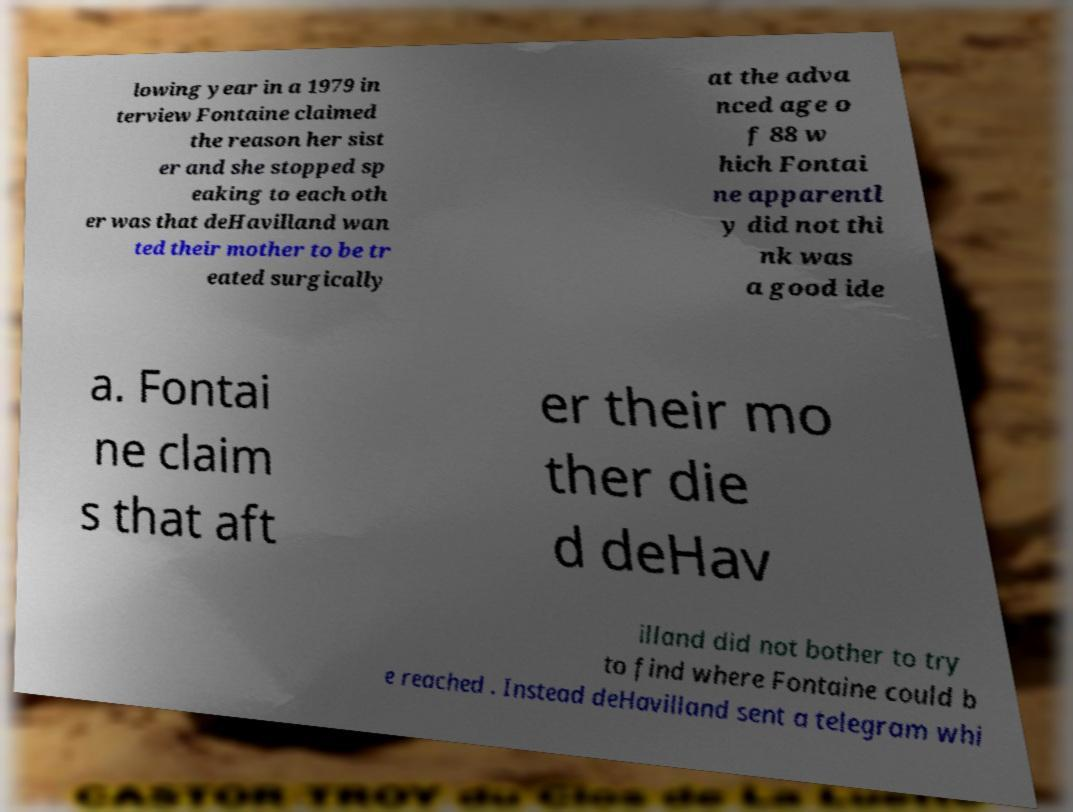Can you read and provide the text displayed in the image?This photo seems to have some interesting text. Can you extract and type it out for me? lowing year in a 1979 in terview Fontaine claimed the reason her sist er and she stopped sp eaking to each oth er was that deHavilland wan ted their mother to be tr eated surgically at the adva nced age o f 88 w hich Fontai ne apparentl y did not thi nk was a good ide a. Fontai ne claim s that aft er their mo ther die d deHav illand did not bother to try to find where Fontaine could b e reached . Instead deHavilland sent a telegram whi 